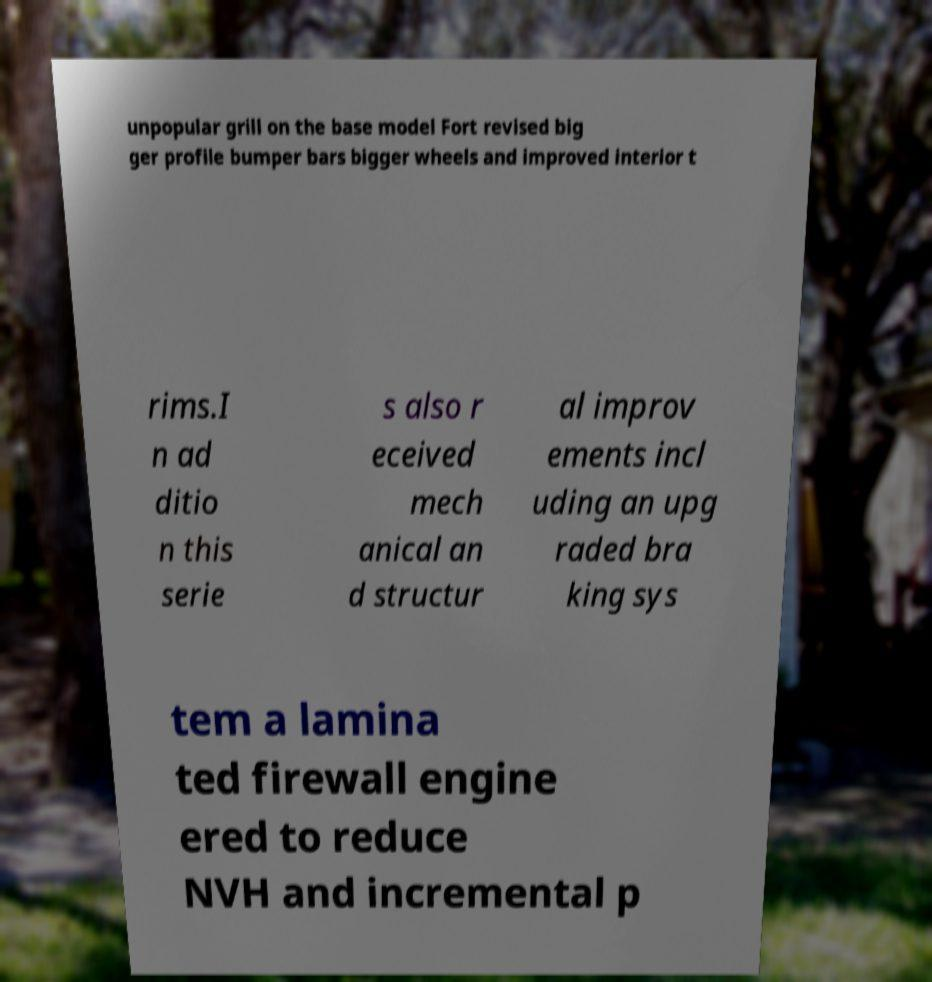There's text embedded in this image that I need extracted. Can you transcribe it verbatim? unpopular grill on the base model Fort revised big ger profile bumper bars bigger wheels and improved interior t rims.I n ad ditio n this serie s also r eceived mech anical an d structur al improv ements incl uding an upg raded bra king sys tem a lamina ted firewall engine ered to reduce NVH and incremental p 